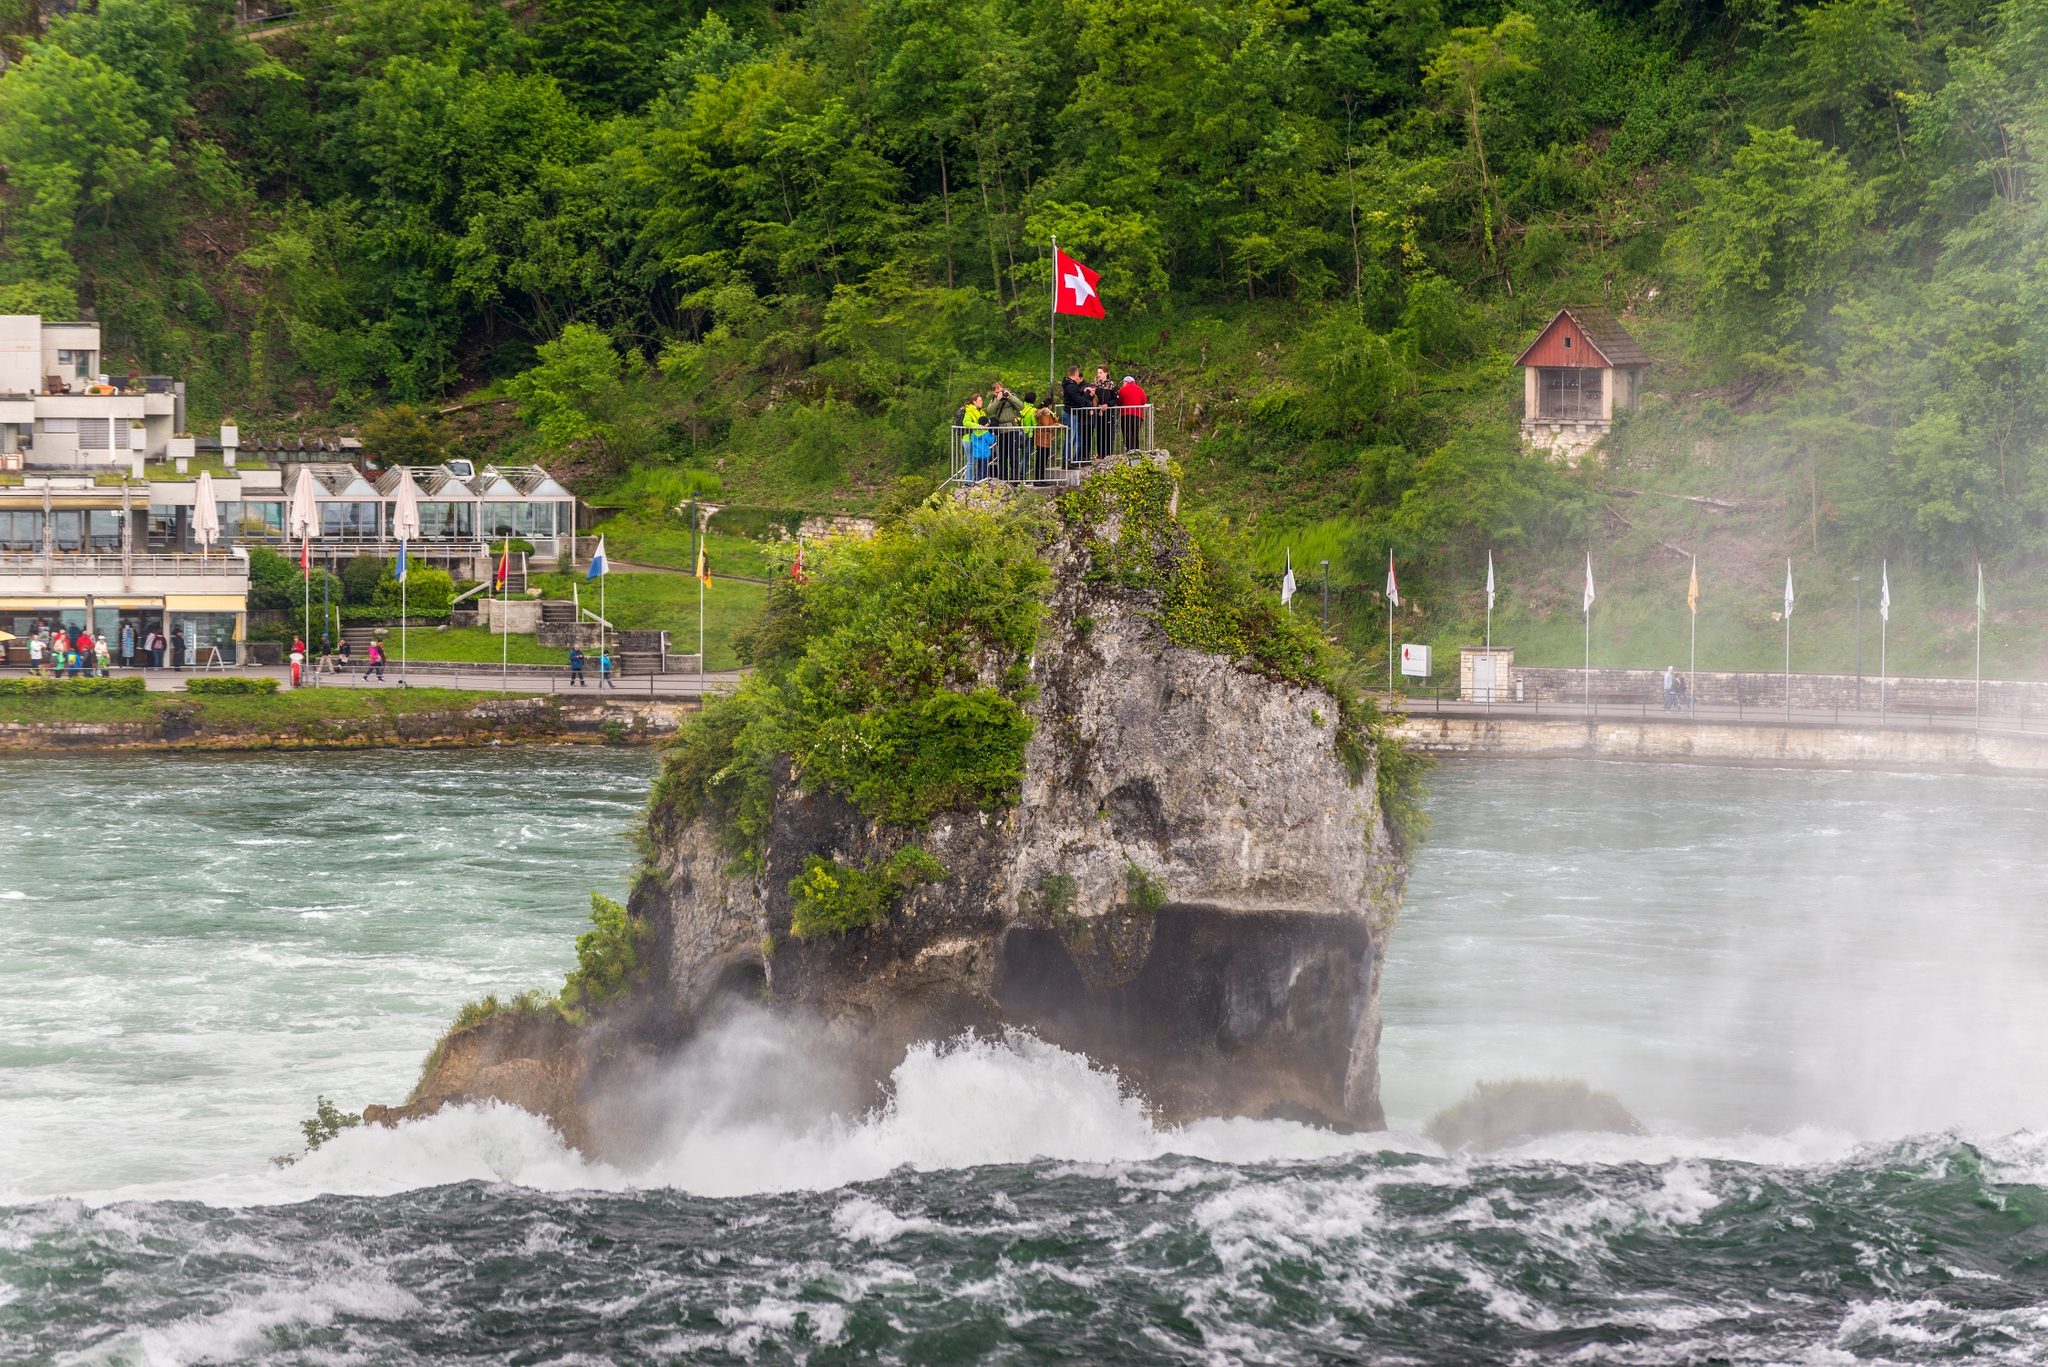What kind of activities might visitors engage in at this location? Visitors to Rhine Falls can enjoy a variety of activities including boat trips that take them close to the waterfalls for a spectacular view, hiking trails around the area for those who appreciate scenic walks, and viewing platforms like the one seen on the rock formation for photo opportunities and observing the waterfall's majesty. There are also souvenir shops and small cafes nearby where tourists can buy local crafts and enjoy traditional Swiss refreshments. Are there specific times of the year that are best for visiting Rhine Falls? The best times to visit Rhine Falls are during the late spring and summer months, from May to September, when the weather is most favorable for outdoor activities. Additionally, the water volume is at its peak during June and July, due to the melting snow from the Alps, making the falls even more spectacular. 